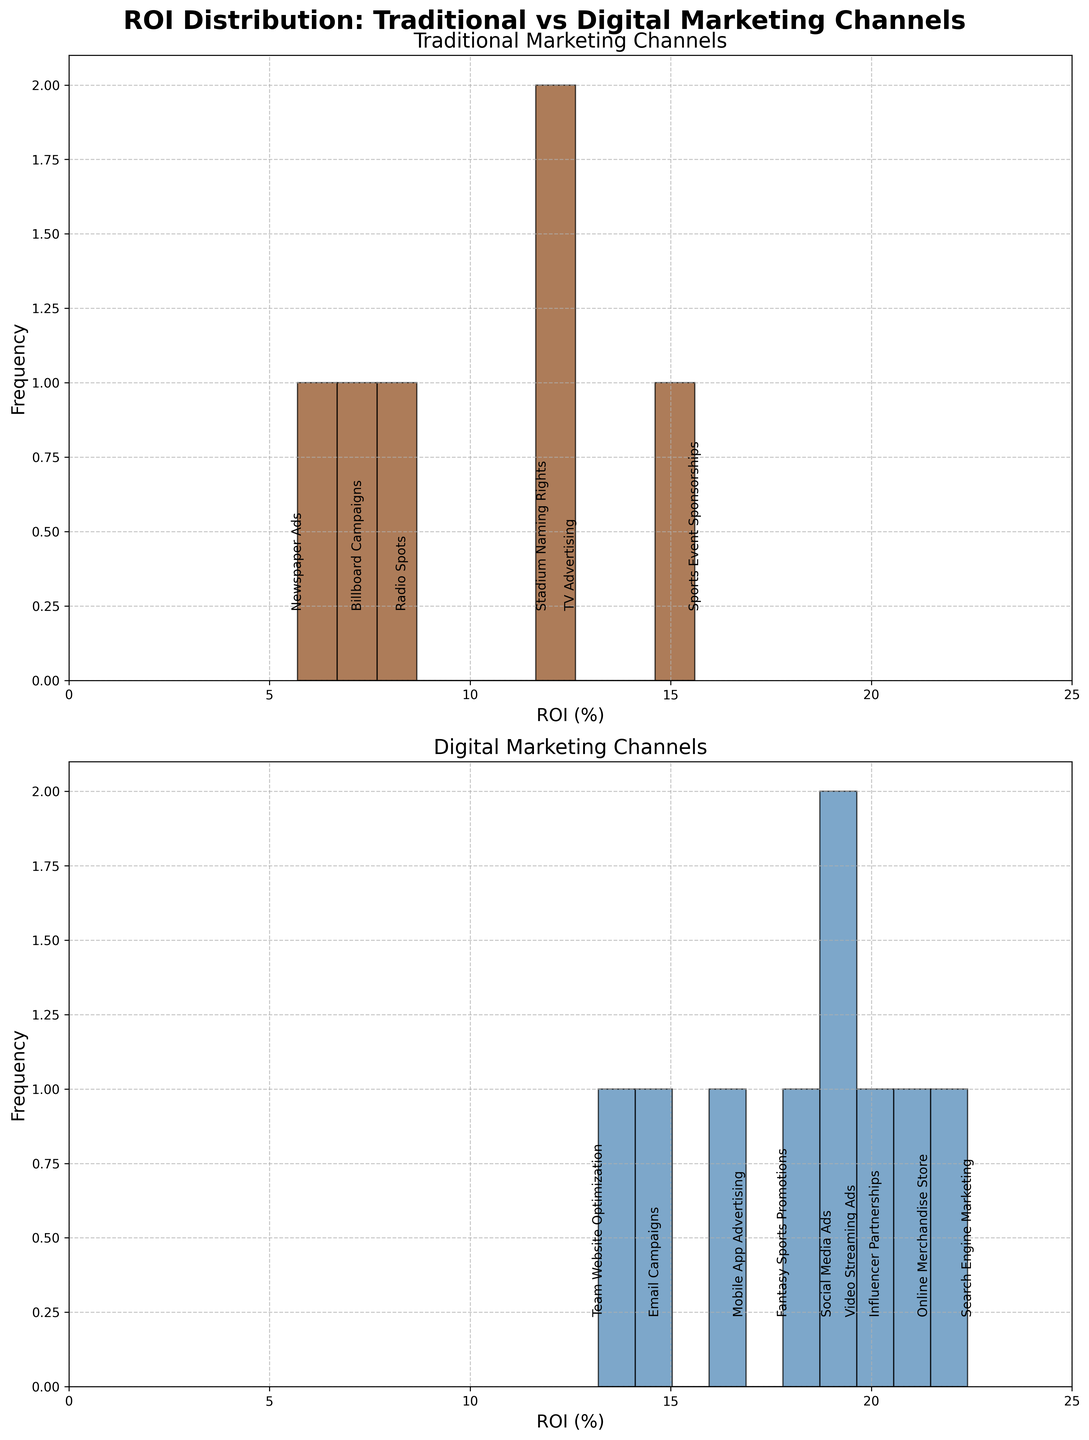Which marketing channel has the highest Return on Investment (ROI) in the traditional category? The histogram for traditional marketing channels shows various bars with ROI values annotated. The highest ROI annotation is 15.6% for Sports Event Sponsorships.
Answer: Sports Event Sponsorships What is the range of ROI values for digital marketing channels? The histogram for digital marketing channels shows the spread of ROI values from the lowest to the highest. The range starts from the lowest ROI value of 13.2% (Team Website Optimization) and goes up to the highest ROI value of 22.4% (Search Engine Marketing).
Answer: 13.2% to 22.4% How many traditional marketing activities have an ROI greater than 10%? By observing the traditional marketing channels' histogram and the annotated ROI values, the activities with ROI values greater than 10% are TV Advertising (12.5%), Sports Event Sponsorships (15.6%), and Stadium Naming Rights (11.8%). By counting these, the total is 3.
Answer: 3 Which type of marketing channel generally yields higher ROIs, traditional or digital? By comparing the two histograms, the ROI values in the digital marketing channels histogram generally seem higher, with values frequently above 15%, while the traditional marketing channels have a more spread distribution with fewer values above 15%.
Answer: Digital What is the approximate average ROI for digital marketing channels? Summing up the ROI values for digital marketing channels: (18.9 + 22.4 + 14.6 + 20.1 + 16.7 + 19.5 + 13.2 + 17.8 + 21.3) which equals 164.5. Since there are 9 digital data points, the average is 164.5 / 9 ≈ 18.3.
Answer: 18.3 Are there any marketing channels with the same ROI in either traditional or digital categories? Examining both histograms for potential identical ROI values, it is observed that no ROI values repeat within the same category.
Answer: No Which traditional marketing channel shows the lowest Return on Investment (ROI) and what is its value? The histogram for traditional marketing channels has annotated ROI values, with the lowest ROI being 5.7% for Newspaper Ads.
Answer: Newspaper Ads, 5.7% How does the ROI distribution for traditional channels compare to that of digital channels? The histogram for traditional channels shows a more varied and spread-out distribution, with values ranging from 5.7% to 15.6%. In contrast, the digital channels have a more compact distribution, generally displaying higher ROI values starting from 13.2% to 22.4%.
Answer: Digital channels show higher and more compact ROI values than traditional channels What's the median ROI value for digital marketing channels? Sorting the digital marketing ROI values: 13.2%, 14.6%, 16.7%, 17.8%, 18.9%, 19.5%, 20.1%, 21.3%, 22.4%. The middle value in this sorted list (the 5th value) is 18.9%.
Answer: 18.9% Which marketing channel stands out as having a particularly high ROI in the digital category? The histogram for digital marketing channels shows several high ROI values, but the highest single ROI is 22.4% for Search Engine Marketing, making it stand out prominently.
Answer: Search Engine Marketing 